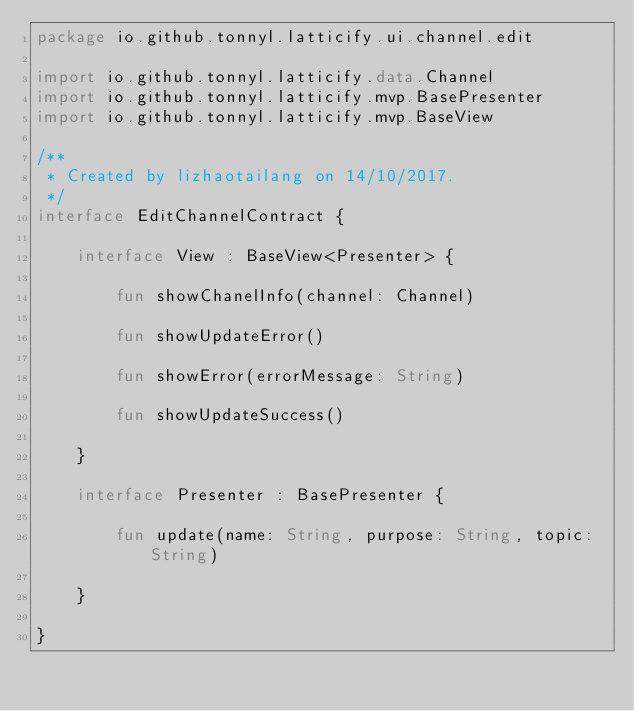Convert code to text. <code><loc_0><loc_0><loc_500><loc_500><_Kotlin_>package io.github.tonnyl.latticify.ui.channel.edit

import io.github.tonnyl.latticify.data.Channel
import io.github.tonnyl.latticify.mvp.BasePresenter
import io.github.tonnyl.latticify.mvp.BaseView

/**
 * Created by lizhaotailang on 14/10/2017.
 */
interface EditChannelContract {

    interface View : BaseView<Presenter> {

        fun showChanelInfo(channel: Channel)

        fun showUpdateError()

        fun showError(errorMessage: String)

        fun showUpdateSuccess()

    }

    interface Presenter : BasePresenter {

        fun update(name: String, purpose: String, topic: String)

    }

}</code> 